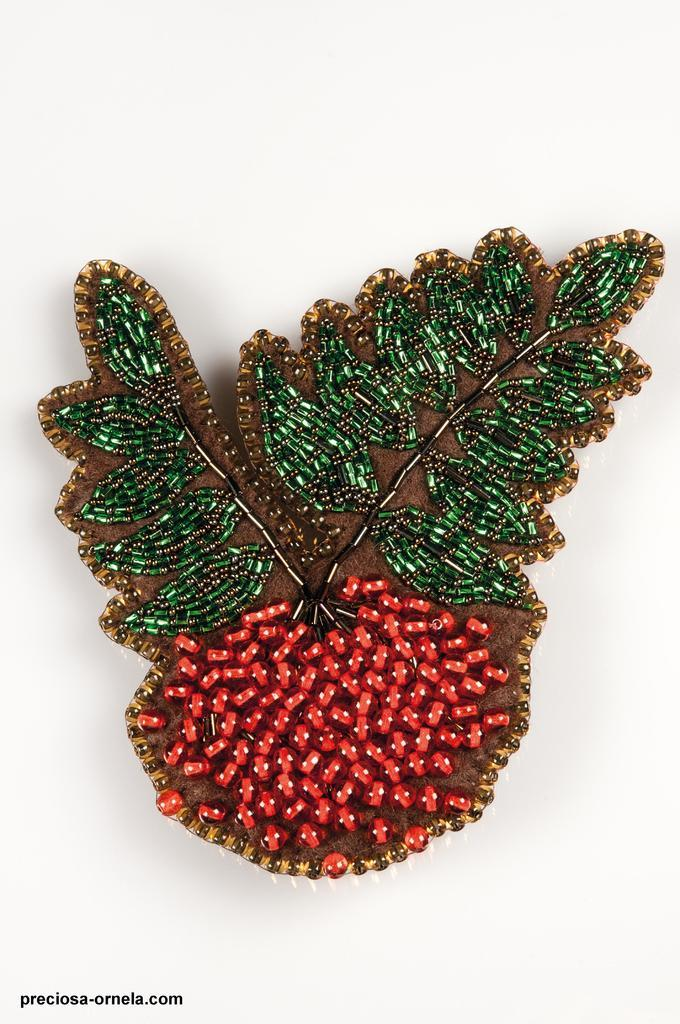What is the main subject of the image? The main subject of the image is an artwork. What material was used to create the artwork? The artwork is made using beads. How many rods are used in the artwork? There is no mention of rods in the image or the provided facts, so we cannot determine the number of rods used in the artwork. 